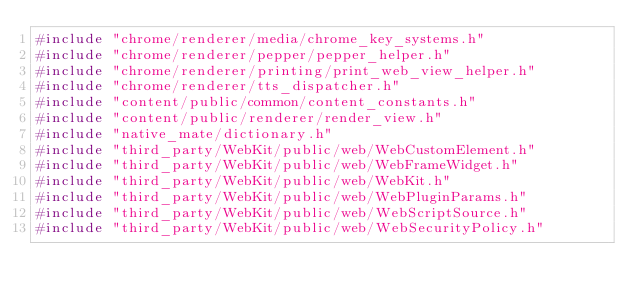Convert code to text. <code><loc_0><loc_0><loc_500><loc_500><_C++_>#include "chrome/renderer/media/chrome_key_systems.h"
#include "chrome/renderer/pepper/pepper_helper.h"
#include "chrome/renderer/printing/print_web_view_helper.h"
#include "chrome/renderer/tts_dispatcher.h"
#include "content/public/common/content_constants.h"
#include "content/public/renderer/render_view.h"
#include "native_mate/dictionary.h"
#include "third_party/WebKit/public/web/WebCustomElement.h"
#include "third_party/WebKit/public/web/WebFrameWidget.h"
#include "third_party/WebKit/public/web/WebKit.h"
#include "third_party/WebKit/public/web/WebPluginParams.h"
#include "third_party/WebKit/public/web/WebScriptSource.h"
#include "third_party/WebKit/public/web/WebSecurityPolicy.h"</code> 